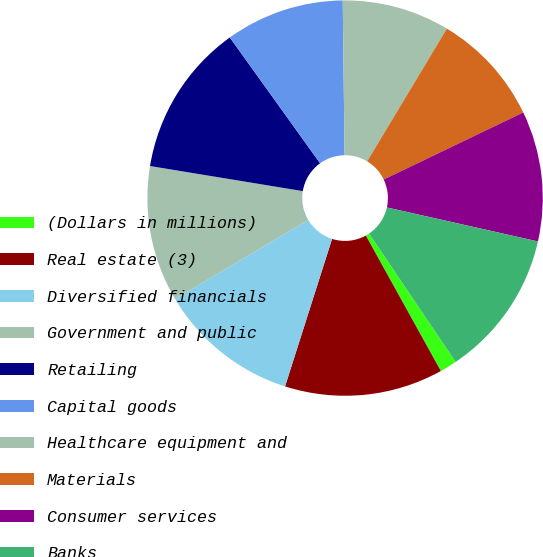<chart> <loc_0><loc_0><loc_500><loc_500><pie_chart><fcel>(Dollars in millions)<fcel>Real estate (3)<fcel>Diversified financials<fcel>Government and public<fcel>Retailing<fcel>Capital goods<fcel>Healthcare equipment and<fcel>Materials<fcel>Consumer services<fcel>Banks<nl><fcel>1.4%<fcel>12.96%<fcel>11.57%<fcel>11.11%<fcel>12.5%<fcel>9.72%<fcel>8.8%<fcel>9.26%<fcel>10.65%<fcel>12.03%<nl></chart> 